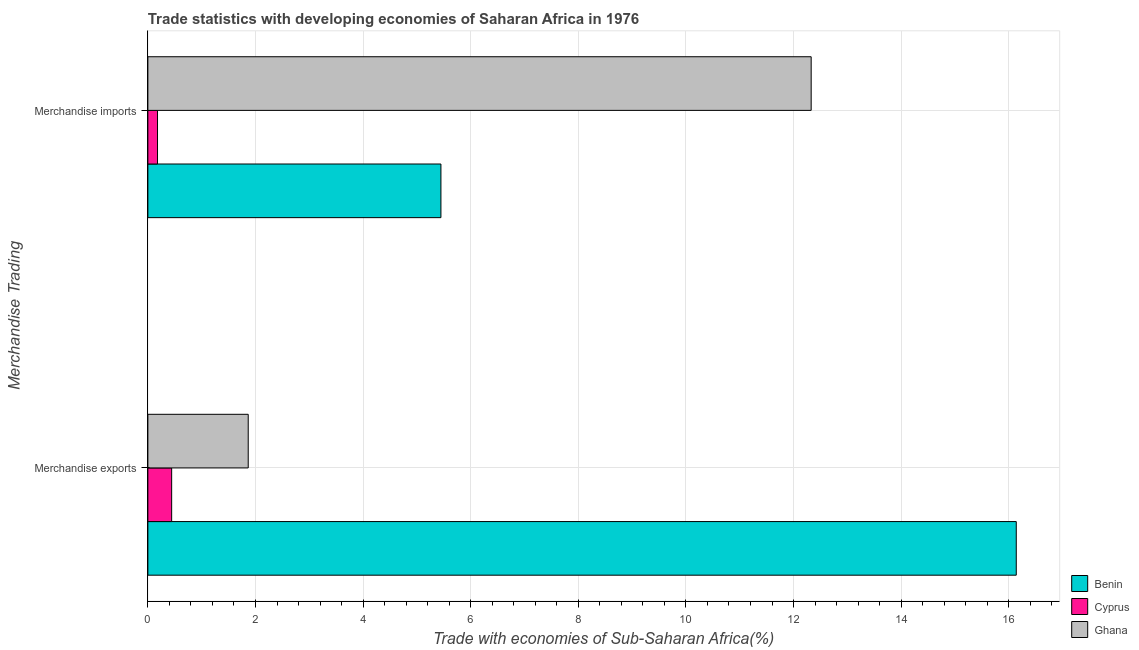How many different coloured bars are there?
Your response must be concise. 3. How many groups of bars are there?
Keep it short and to the point. 2. Are the number of bars per tick equal to the number of legend labels?
Offer a very short reply. Yes. What is the label of the 2nd group of bars from the top?
Your response must be concise. Merchandise exports. What is the merchandise exports in Benin?
Your response must be concise. 16.14. Across all countries, what is the maximum merchandise imports?
Ensure brevity in your answer.  12.33. Across all countries, what is the minimum merchandise imports?
Offer a terse response. 0.18. In which country was the merchandise imports maximum?
Provide a succinct answer. Ghana. In which country was the merchandise exports minimum?
Ensure brevity in your answer.  Cyprus. What is the total merchandise exports in the graph?
Your response must be concise. 18.45. What is the difference between the merchandise exports in Benin and that in Ghana?
Ensure brevity in your answer.  14.27. What is the difference between the merchandise imports in Benin and the merchandise exports in Cyprus?
Offer a very short reply. 5. What is the average merchandise imports per country?
Your answer should be compact. 5.98. What is the difference between the merchandise imports and merchandise exports in Ghana?
Offer a very short reply. 10.46. In how many countries, is the merchandise exports greater than 7.2 %?
Your response must be concise. 1. What is the ratio of the merchandise exports in Cyprus to that in Benin?
Provide a short and direct response. 0.03. What does the 3rd bar from the top in Merchandise imports represents?
Give a very brief answer. Benin. What does the 3rd bar from the bottom in Merchandise exports represents?
Your answer should be very brief. Ghana. How many bars are there?
Provide a short and direct response. 6. Are all the bars in the graph horizontal?
Your answer should be very brief. Yes. How many countries are there in the graph?
Provide a short and direct response. 3. Does the graph contain any zero values?
Ensure brevity in your answer.  No. How many legend labels are there?
Provide a succinct answer. 3. What is the title of the graph?
Provide a succinct answer. Trade statistics with developing economies of Saharan Africa in 1976. Does "Spain" appear as one of the legend labels in the graph?
Make the answer very short. No. What is the label or title of the X-axis?
Make the answer very short. Trade with economies of Sub-Saharan Africa(%). What is the label or title of the Y-axis?
Your response must be concise. Merchandise Trading. What is the Trade with economies of Sub-Saharan Africa(%) of Benin in Merchandise exports?
Ensure brevity in your answer.  16.14. What is the Trade with economies of Sub-Saharan Africa(%) in Cyprus in Merchandise exports?
Your answer should be very brief. 0.44. What is the Trade with economies of Sub-Saharan Africa(%) of Ghana in Merchandise exports?
Keep it short and to the point. 1.87. What is the Trade with economies of Sub-Saharan Africa(%) of Benin in Merchandise imports?
Your response must be concise. 5.45. What is the Trade with economies of Sub-Saharan Africa(%) of Cyprus in Merchandise imports?
Provide a succinct answer. 0.18. What is the Trade with economies of Sub-Saharan Africa(%) of Ghana in Merchandise imports?
Offer a terse response. 12.33. Across all Merchandise Trading, what is the maximum Trade with economies of Sub-Saharan Africa(%) in Benin?
Make the answer very short. 16.14. Across all Merchandise Trading, what is the maximum Trade with economies of Sub-Saharan Africa(%) in Cyprus?
Provide a short and direct response. 0.44. Across all Merchandise Trading, what is the maximum Trade with economies of Sub-Saharan Africa(%) in Ghana?
Provide a short and direct response. 12.33. Across all Merchandise Trading, what is the minimum Trade with economies of Sub-Saharan Africa(%) in Benin?
Give a very brief answer. 5.45. Across all Merchandise Trading, what is the minimum Trade with economies of Sub-Saharan Africa(%) in Cyprus?
Make the answer very short. 0.18. Across all Merchandise Trading, what is the minimum Trade with economies of Sub-Saharan Africa(%) of Ghana?
Provide a short and direct response. 1.87. What is the total Trade with economies of Sub-Saharan Africa(%) of Benin in the graph?
Your answer should be very brief. 21.59. What is the total Trade with economies of Sub-Saharan Africa(%) in Cyprus in the graph?
Offer a terse response. 0.62. What is the total Trade with economies of Sub-Saharan Africa(%) of Ghana in the graph?
Provide a succinct answer. 14.19. What is the difference between the Trade with economies of Sub-Saharan Africa(%) of Benin in Merchandise exports and that in Merchandise imports?
Make the answer very short. 10.69. What is the difference between the Trade with economies of Sub-Saharan Africa(%) of Cyprus in Merchandise exports and that in Merchandise imports?
Your response must be concise. 0.26. What is the difference between the Trade with economies of Sub-Saharan Africa(%) in Ghana in Merchandise exports and that in Merchandise imports?
Offer a very short reply. -10.46. What is the difference between the Trade with economies of Sub-Saharan Africa(%) of Benin in Merchandise exports and the Trade with economies of Sub-Saharan Africa(%) of Cyprus in Merchandise imports?
Your response must be concise. 15.96. What is the difference between the Trade with economies of Sub-Saharan Africa(%) in Benin in Merchandise exports and the Trade with economies of Sub-Saharan Africa(%) in Ghana in Merchandise imports?
Make the answer very short. 3.81. What is the difference between the Trade with economies of Sub-Saharan Africa(%) in Cyprus in Merchandise exports and the Trade with economies of Sub-Saharan Africa(%) in Ghana in Merchandise imports?
Keep it short and to the point. -11.89. What is the average Trade with economies of Sub-Saharan Africa(%) in Benin per Merchandise Trading?
Your response must be concise. 10.79. What is the average Trade with economies of Sub-Saharan Africa(%) in Cyprus per Merchandise Trading?
Make the answer very short. 0.31. What is the average Trade with economies of Sub-Saharan Africa(%) in Ghana per Merchandise Trading?
Give a very brief answer. 7.1. What is the difference between the Trade with economies of Sub-Saharan Africa(%) in Benin and Trade with economies of Sub-Saharan Africa(%) in Cyprus in Merchandise exports?
Your answer should be very brief. 15.7. What is the difference between the Trade with economies of Sub-Saharan Africa(%) of Benin and Trade with economies of Sub-Saharan Africa(%) of Ghana in Merchandise exports?
Ensure brevity in your answer.  14.27. What is the difference between the Trade with economies of Sub-Saharan Africa(%) of Cyprus and Trade with economies of Sub-Saharan Africa(%) of Ghana in Merchandise exports?
Offer a terse response. -1.42. What is the difference between the Trade with economies of Sub-Saharan Africa(%) of Benin and Trade with economies of Sub-Saharan Africa(%) of Cyprus in Merchandise imports?
Make the answer very short. 5.27. What is the difference between the Trade with economies of Sub-Saharan Africa(%) in Benin and Trade with economies of Sub-Saharan Africa(%) in Ghana in Merchandise imports?
Offer a very short reply. -6.88. What is the difference between the Trade with economies of Sub-Saharan Africa(%) of Cyprus and Trade with economies of Sub-Saharan Africa(%) of Ghana in Merchandise imports?
Offer a very short reply. -12.15. What is the ratio of the Trade with economies of Sub-Saharan Africa(%) in Benin in Merchandise exports to that in Merchandise imports?
Your response must be concise. 2.96. What is the ratio of the Trade with economies of Sub-Saharan Africa(%) of Cyprus in Merchandise exports to that in Merchandise imports?
Ensure brevity in your answer.  2.47. What is the ratio of the Trade with economies of Sub-Saharan Africa(%) of Ghana in Merchandise exports to that in Merchandise imports?
Offer a terse response. 0.15. What is the difference between the highest and the second highest Trade with economies of Sub-Saharan Africa(%) in Benin?
Keep it short and to the point. 10.69. What is the difference between the highest and the second highest Trade with economies of Sub-Saharan Africa(%) of Cyprus?
Provide a short and direct response. 0.26. What is the difference between the highest and the second highest Trade with economies of Sub-Saharan Africa(%) of Ghana?
Make the answer very short. 10.46. What is the difference between the highest and the lowest Trade with economies of Sub-Saharan Africa(%) in Benin?
Your answer should be compact. 10.69. What is the difference between the highest and the lowest Trade with economies of Sub-Saharan Africa(%) of Cyprus?
Make the answer very short. 0.26. What is the difference between the highest and the lowest Trade with economies of Sub-Saharan Africa(%) of Ghana?
Provide a short and direct response. 10.46. 